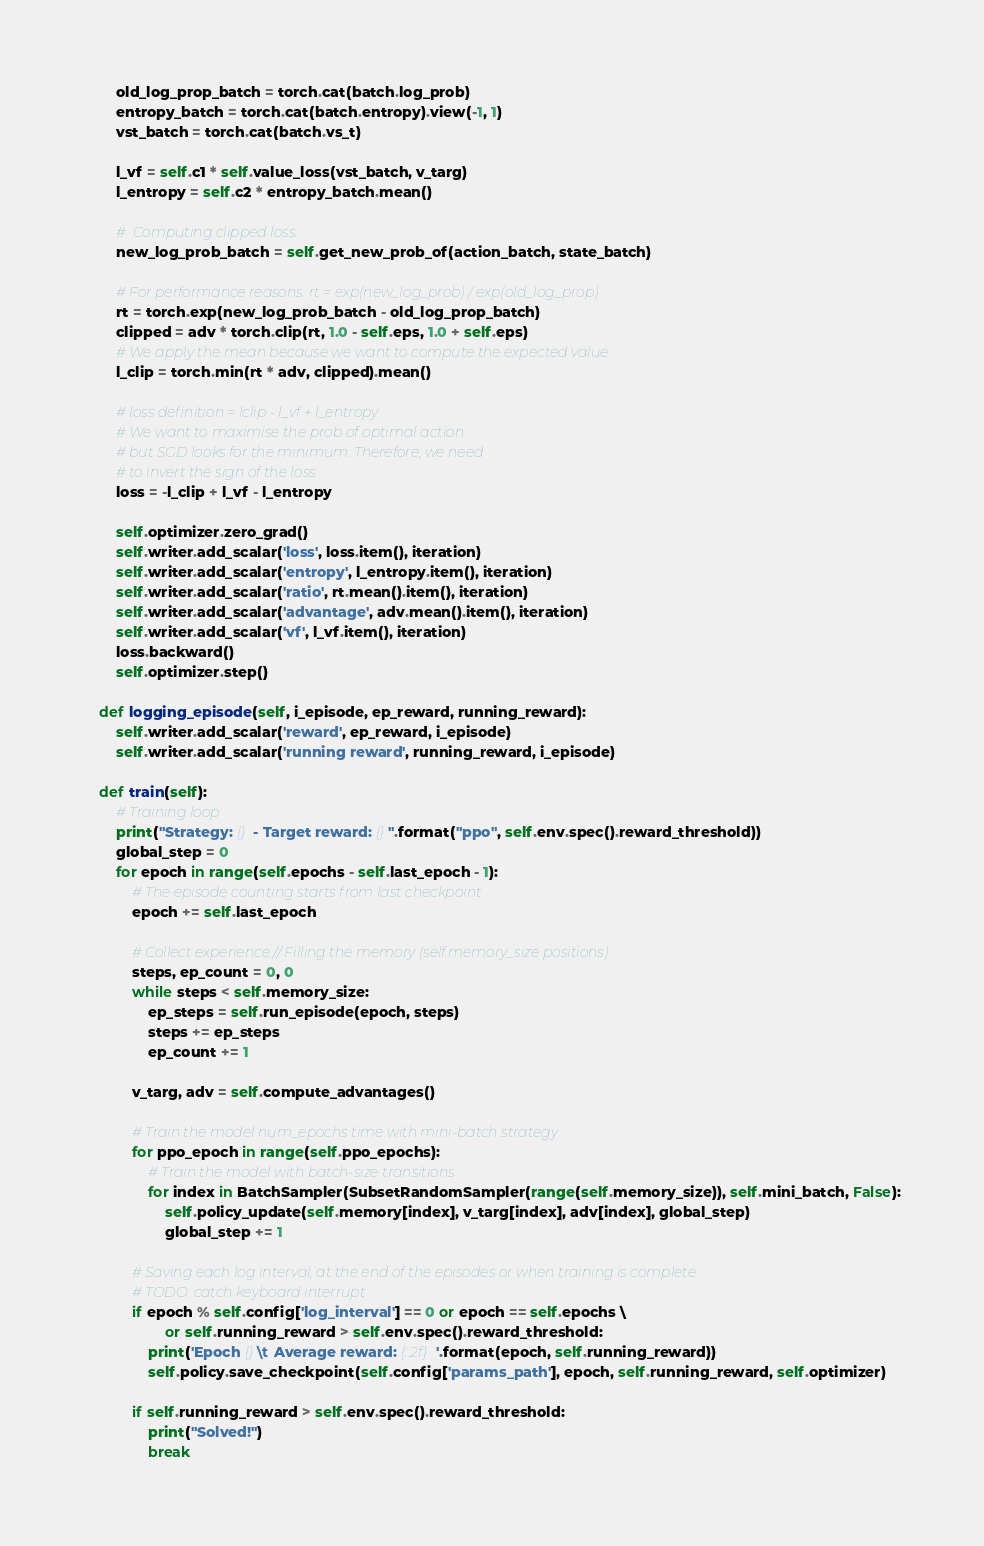Convert code to text. <code><loc_0><loc_0><loc_500><loc_500><_Python_>        old_log_prop_batch = torch.cat(batch.log_prob)
        entropy_batch = torch.cat(batch.entropy).view(-1, 1)
        vst_batch = torch.cat(batch.vs_t)

        l_vf = self.c1 * self.value_loss(vst_batch, v_targ)
        l_entropy = self.c2 * entropy_batch.mean()

        #  Computing clipped loss:
        new_log_prob_batch = self.get_new_prob_of(action_batch, state_batch)

        # For performance reasons. rt = exp(new_log_prob) / exp(old_log_prop)
        rt = torch.exp(new_log_prob_batch - old_log_prop_batch)
        clipped = adv * torch.clip(rt, 1.0 - self.eps, 1.0 + self.eps)
        # We apply the mean because we want to compute the expected value
        l_clip = torch.min(rt * adv, clipped).mean()

        # loss definition = lclip - l_vf + l_entropy
        # We want to maximise the prob of optimal action
        # but SGD looks for the minimum. Therefore, we need
        # to invert the sign of the loss.
        loss = -l_clip + l_vf - l_entropy

        self.optimizer.zero_grad()
        self.writer.add_scalar('loss', loss.item(), iteration)
        self.writer.add_scalar('entropy', l_entropy.item(), iteration)
        self.writer.add_scalar('ratio', rt.mean().item(), iteration)
        self.writer.add_scalar('advantage', adv.mean().item(), iteration)
        self.writer.add_scalar('vf', l_vf.item(), iteration)
        loss.backward()
        self.optimizer.step()

    def logging_episode(self, i_episode, ep_reward, running_reward):
        self.writer.add_scalar('reward', ep_reward, i_episode)
        self.writer.add_scalar('running reward', running_reward, i_episode)

    def train(self):
        # Training loop
        print("Strategy: {} - Target reward: {}".format("ppo", self.env.spec().reward_threshold))
        global_step = 0
        for epoch in range(self.epochs - self.last_epoch - 1):
            # The episode counting starts from last checkpoint
            epoch += self.last_epoch

            # Collect experience // Filling the memory (self.memory_size positions)
            steps, ep_count = 0, 0
            while steps < self.memory_size:
                ep_steps = self.run_episode(epoch, steps)
                steps += ep_steps
                ep_count += 1

            v_targ, adv = self.compute_advantages()

            # Train the model num_epochs time with mini-batch strategy
            for ppo_epoch in range(self.ppo_epochs):
                # Train the model with batch-size transitions
                for index in BatchSampler(SubsetRandomSampler(range(self.memory_size)), self.mini_batch, False):
                    self.policy_update(self.memory[index], v_targ[index], adv[index], global_step)
                    global_step += 1

            # Saving each log interval, at the end of the episodes or when training is complete
            # TODO: catch keyboard interrupt
            if epoch % self.config['log_interval'] == 0 or epoch == self.epochs \
                    or self.running_reward > self.env.spec().reward_threshold:
                print('Epoch {}\t Average reward: {:.2f}'.format(epoch, self.running_reward))
                self.policy.save_checkpoint(self.config['params_path'], epoch, self.running_reward, self.optimizer)

            if self.running_reward > self.env.spec().reward_threshold:
                print("Solved!")
                break
</code> 